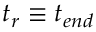<formula> <loc_0><loc_0><loc_500><loc_500>t _ { r } \equiv t _ { e n d }</formula> 